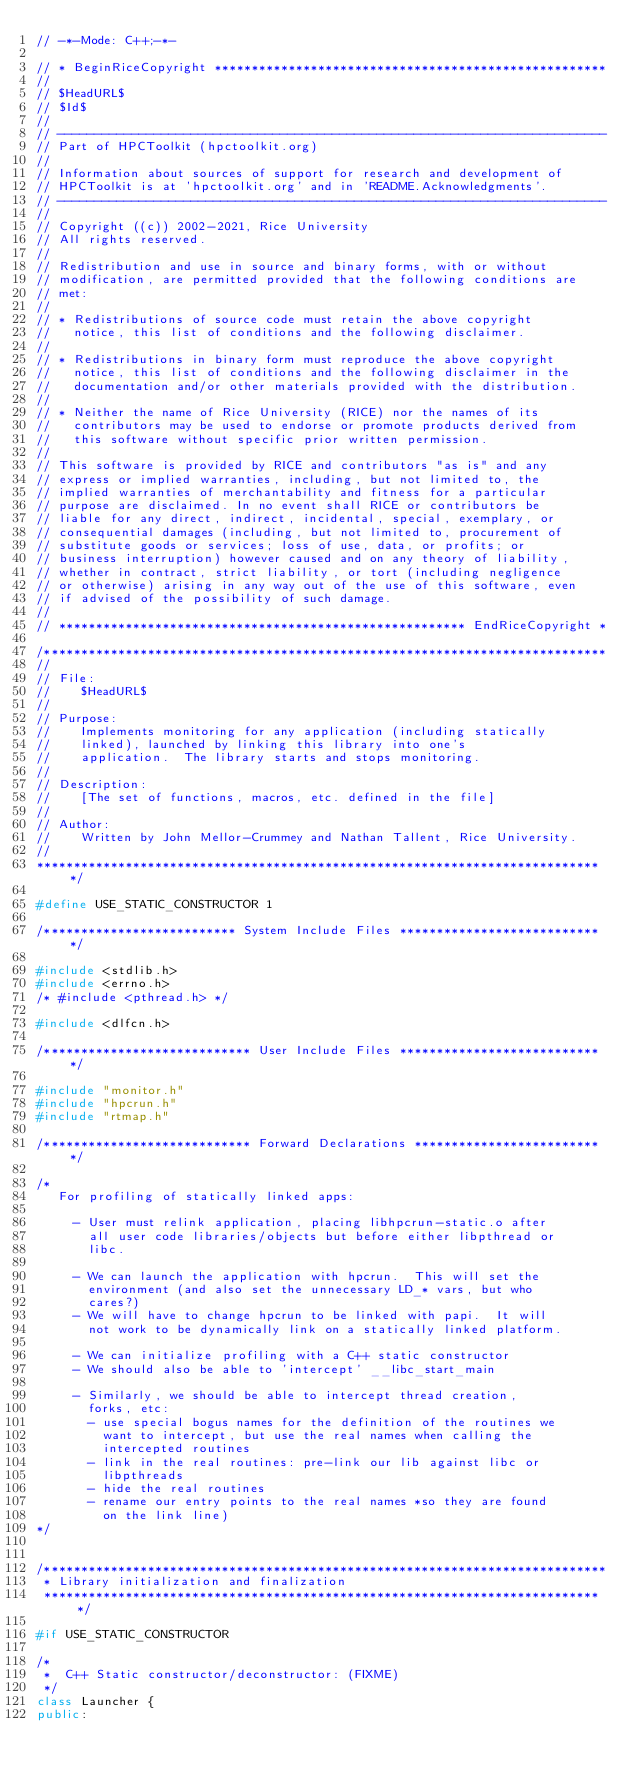<code> <loc_0><loc_0><loc_500><loc_500><_C++_>// -*-Mode: C++;-*-

// * BeginRiceCopyright *****************************************************
//
// $HeadURL$
// $Id$
//
// --------------------------------------------------------------------------
// Part of HPCToolkit (hpctoolkit.org)
//
// Information about sources of support for research and development of
// HPCToolkit is at 'hpctoolkit.org' and in 'README.Acknowledgments'.
// --------------------------------------------------------------------------
//
// Copyright ((c)) 2002-2021, Rice University
// All rights reserved.
//
// Redistribution and use in source and binary forms, with or without
// modification, are permitted provided that the following conditions are
// met:
//
// * Redistributions of source code must retain the above copyright
//   notice, this list of conditions and the following disclaimer.
//
// * Redistributions in binary form must reproduce the above copyright
//   notice, this list of conditions and the following disclaimer in the
//   documentation and/or other materials provided with the distribution.
//
// * Neither the name of Rice University (RICE) nor the names of its
//   contributors may be used to endorse or promote products derived from
//   this software without specific prior written permission.
//
// This software is provided by RICE and contributors "as is" and any
// express or implied warranties, including, but not limited to, the
// implied warranties of merchantability and fitness for a particular
// purpose are disclaimed. In no event shall RICE or contributors be
// liable for any direct, indirect, incidental, special, exemplary, or
// consequential damages (including, but not limited to, procurement of
// substitute goods or services; loss of use, data, or profits; or
// business interruption) however caused and on any theory of liability,
// whether in contract, strict liability, or tort (including negligence
// or otherwise) arising in any way out of the use of this software, even
// if advised of the possibility of such damage.
//
// ******************************************************* EndRiceCopyright *

/****************************************************************************
//
// File: 
//    $HeadURL$
//
// Purpose:
//    Implements monitoring for any application (including statically
//    linked), launched by linking this library into one's
//    application.  The library starts and stops monitoring.
//
// Description:
//    [The set of functions, macros, etc. defined in the file]
//
// Author:
//    Written by John Mellor-Crummey and Nathan Tallent, Rice University.
//
*****************************************************************************/

#define USE_STATIC_CONSTRUCTOR 1

/************************** System Include Files ****************************/

#include <stdlib.h>
#include <errno.h>
/* #include <pthread.h> */

#include <dlfcn.h>

/**************************** User Include Files ****************************/

#include "monitor.h"
#include "hpcrun.h"
#include "rtmap.h"

/**************************** Forward Declarations **************************/

/* 
   For profiling of statically linked apps:
  
     - User must relink application, placing libhpcrun-static.o after
       all user code libraries/objects but before either libpthread or
       libc.

     - We can launch the application with hpcrun.  This will set the
       environment (and also set the unnecessary LD_* vars, but who
       cares?)
     - We will have to change hpcrun to be linked with papi.  It will
       not work to be dynamically link on a statically linked platform.

     - We can initialize profiling with a C++ static constructor
     - We should also be able to 'intercept' __libc_start_main

     - Similarly, we should be able to intercept thread creation,
       forks, etc:
       - use special bogus names for the definition of the routines we
         want to intercept, but use the real names when calling the
         intercepted routines
       - link in the real routines: pre-link our lib against libc or
         libpthreads
       - hide the real routines
       - rename our entry points to the real names *so they are found
         on the link line)	 
*/


/****************************************************************************
 * Library initialization and finalization
 ****************************************************************************/

#if USE_STATIC_CONSTRUCTOR

/*
 *  C++ Static constructor/deconstructor: (FIXME)
 */
class Launcher {
public:</code> 